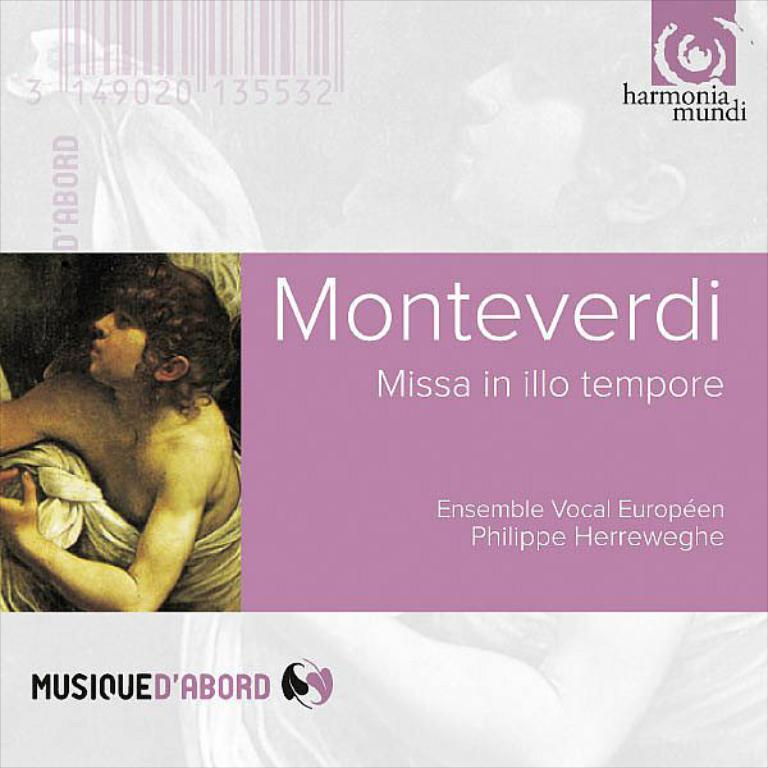What is the main feature in the center of the image? There is text in the center of the image. Can you describe any other elements in the image? Yes, there is a photo of a person in the image. What type of cork can be seen in the image? There is no cork present in the image. How does the cook appear in the image? There is no cook or cooking activity depicted in the image. 